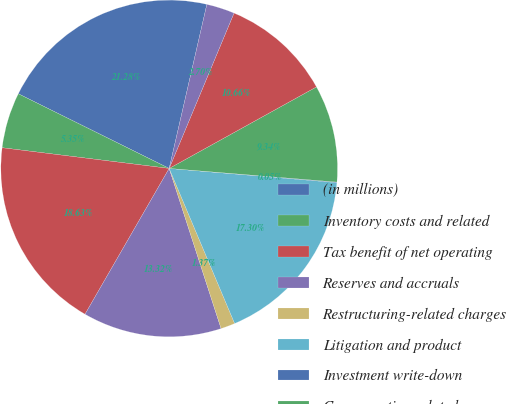Convert chart. <chart><loc_0><loc_0><loc_500><loc_500><pie_chart><fcel>(in millions)<fcel>Inventory costs and related<fcel>Tax benefit of net operating<fcel>Reserves and accruals<fcel>Restructuring-related charges<fcel>Litigation and product<fcel>Investment write-down<fcel>Compensation related<fcel>Federal benefit of uncertain<fcel>Other<nl><fcel>21.28%<fcel>5.35%<fcel>18.63%<fcel>13.32%<fcel>1.37%<fcel>17.3%<fcel>0.05%<fcel>9.34%<fcel>10.66%<fcel>2.7%<nl></chart> 